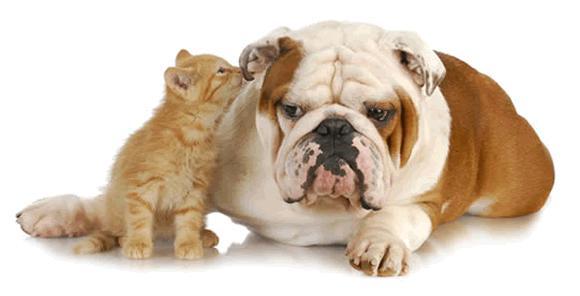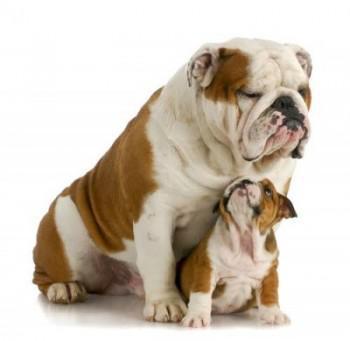The first image is the image on the left, the second image is the image on the right. Evaluate the accuracy of this statement regarding the images: "One of the images features a dog that is wearing a collar.". Is it true? Answer yes or no. No. The first image is the image on the left, the second image is the image on the right. Given the left and right images, does the statement "Each image contains a single dog, which is gazing toward the front and has its mouth closed." hold true? Answer yes or no. No. 